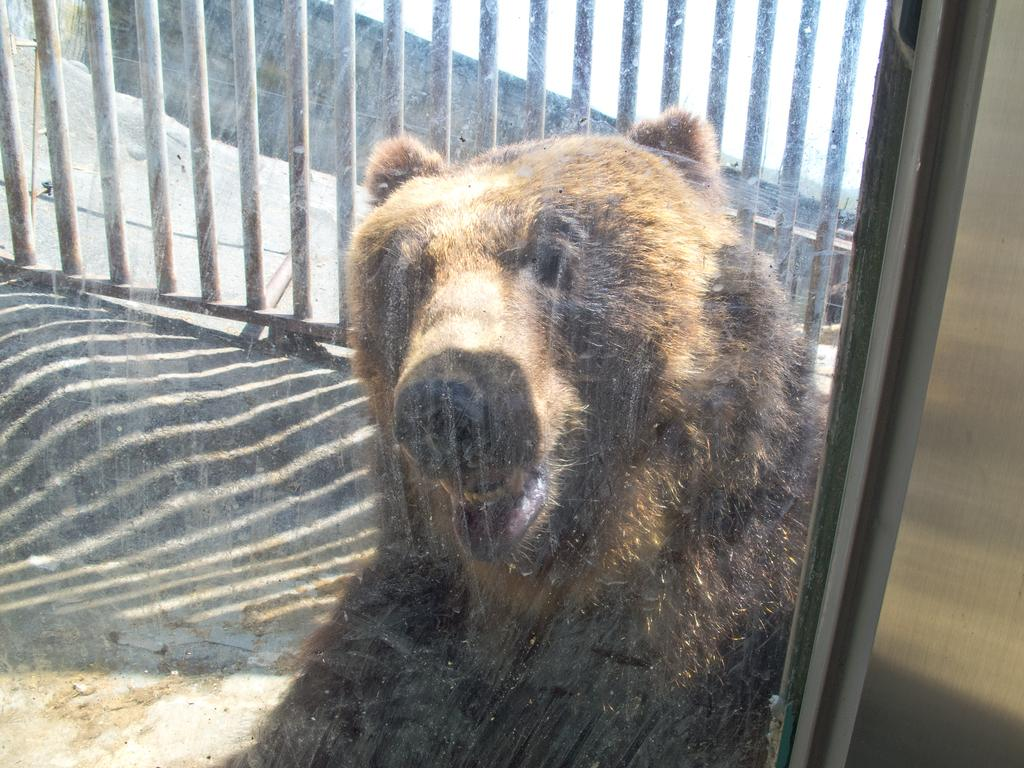What is in the foreground of the image? There is a glass door in the foreground of the image. What can be seen through the glass door? There is a bear behind the glass door. What is located behind the bear? There is a fence behind the bear. What is visible on the right side of the image? There is a wall on the right side of the image. What type of joke is the bear telling through the glass door in the image? There is no indication in the image that the bear is telling a joke or communicating in any way. 